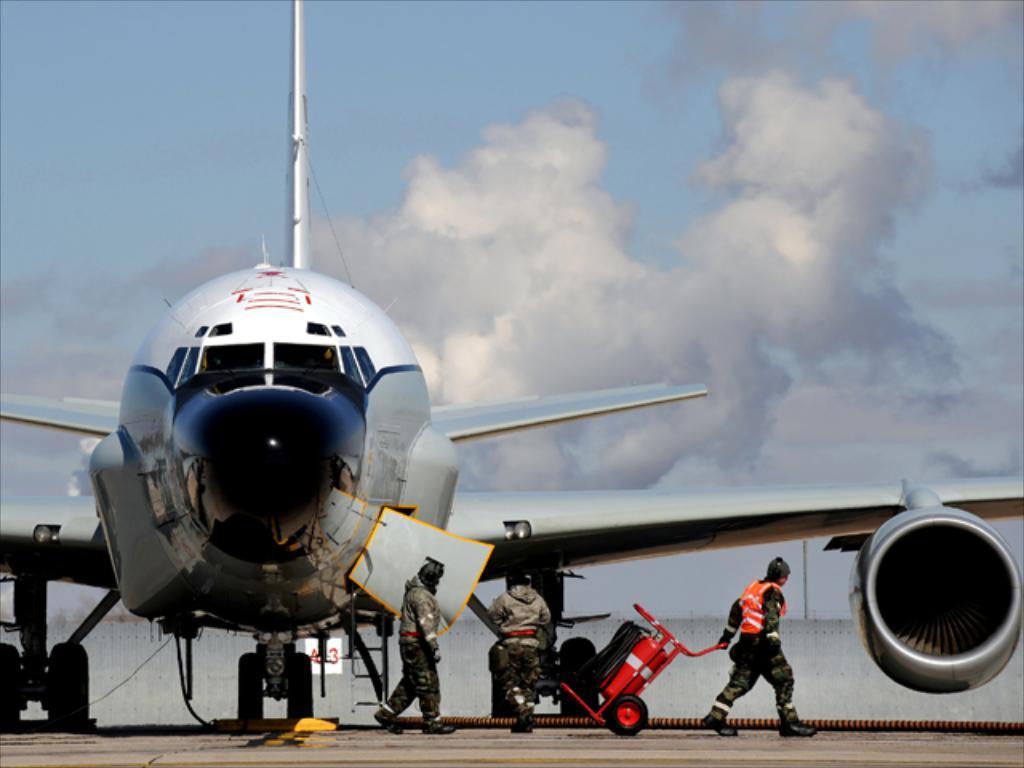Describe this image in one or two sentences. There are people and an aircraft in the foreground area of the image and the sky in the background. 